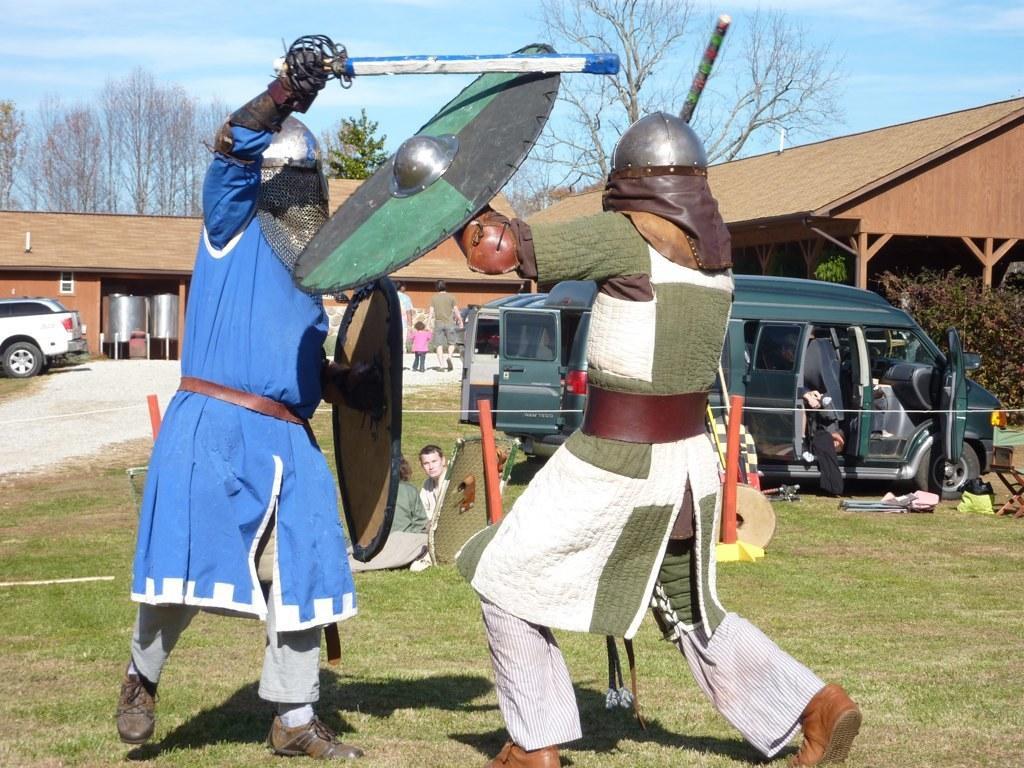In one or two sentences, can you explain what this image depicts? In the picture I can see two men wearing helmet, holding Armour shield, stick in their hands and fighting, in the background of the picture there are some vehicles parked, some persons sitting and walking, there are houses, trees and top of the picture there is clear sky. 